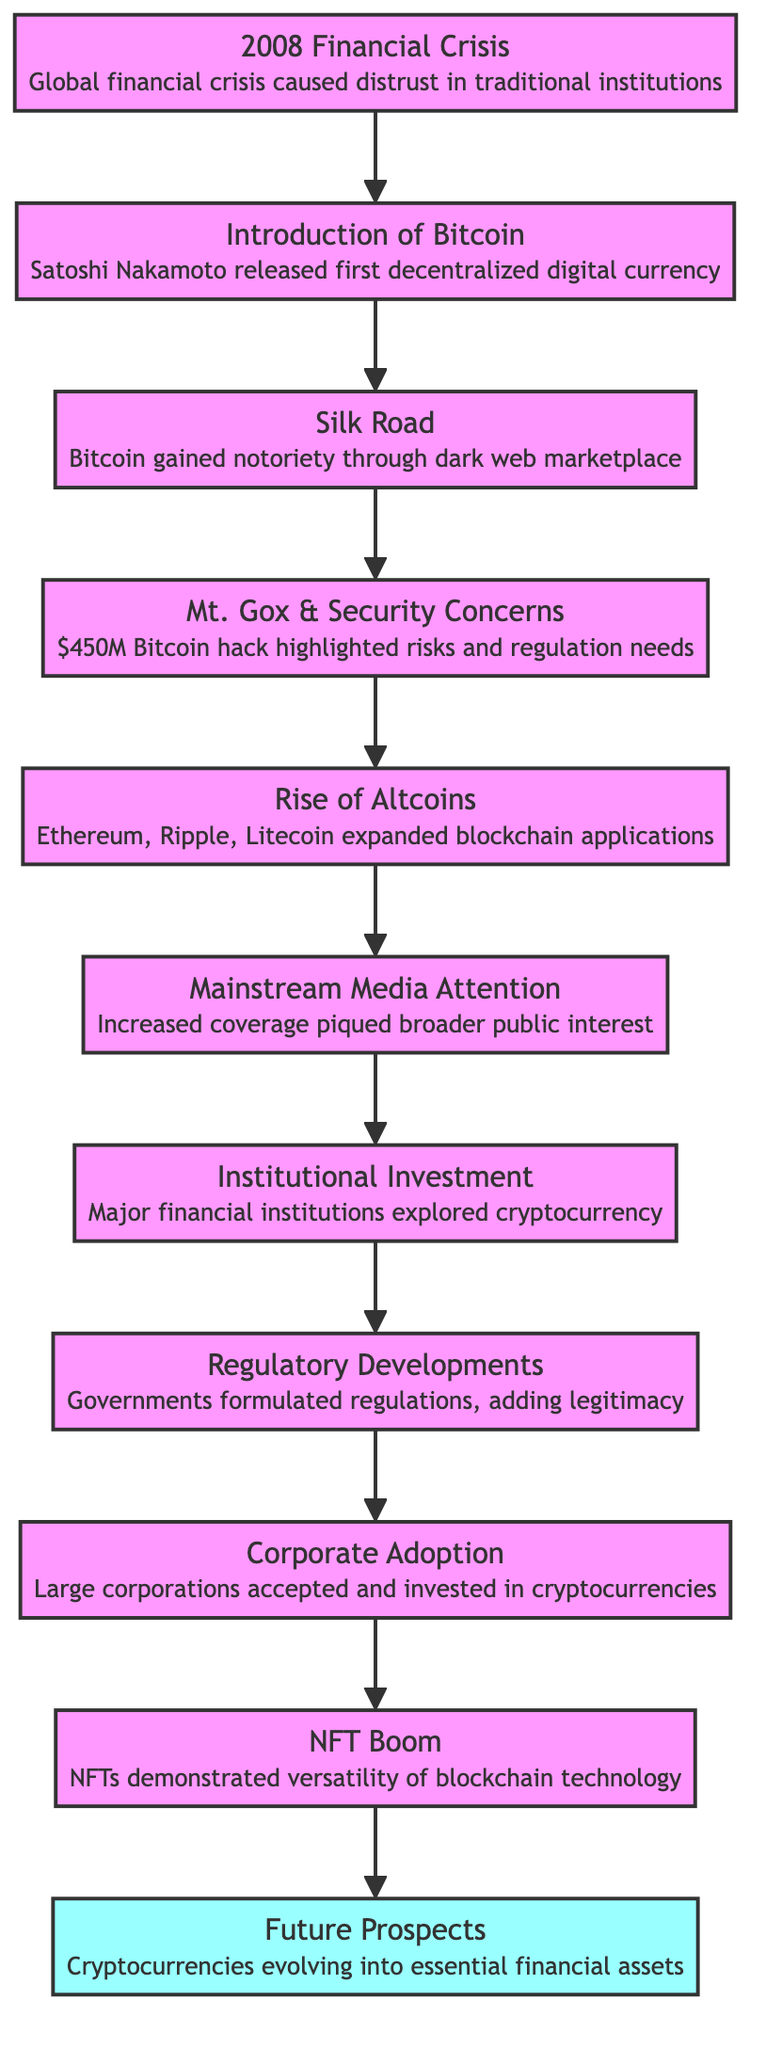What was the first cryptocurrency introduced? The diagram indicates that the first cryptocurrency introduced was Bitcoin in 2009, following the 2008 financial crisis.
Answer: Bitcoin What stage follows the Silk Road in the flow? According to the diagram, the node that follows Silk Road is Mt. Gox & Security Concerns.
Answer: Mt. Gox & Security Concerns How many major nodes are there in the flowchart before corporate adoption? Counting the distinct nodes in the flow that lead to corporate adoption, there are a total of 8 nodes before that stage, from the 2008 Financial Crisis to Mainstream Media Attention.
Answer: 8 What issue did the Mt. Gox incident highlight? The incident involving Mt. Gox highlighted security concerns related to cryptocurrency, as evidenced by the stolen funds and the subsequent discussion on regulation.
Answer: Security concerns Which stage indicates the transition of cryptocurrencies from niche to mainstream? The stage that signifies this transition is Corporate Adoption, where large companies began to integrate cryptocurrencies into their operations, showing mainstream acceptance.
Answer: Corporate Adoption What was the impact of the NFT boom on public attention? The NFT boom demonstrated the versatility of blockchain technology and significantly drew public attention towards various applications of cryptocurrencies, which is shown in the flowchart leading to the Future Prospects.
Answer: Draw public attention In which stage did major financial institutions start exploring cryptocurrencies? The chart specifies that major financial institutions began exploring cryptocurrencies during the Institutional Investment stage, marked as stage 7 in the flow.
Answer: Institutional Investment What regulatory action followed the rise of cryptocurrencies? Following the rise of cryptocurrencies, the chart indicates that Regulatory Developments began as governments formulated regulations to legitimize the markets.
Answer: Regulatory Developments What is the last stage in the flowchart? The last stage in the flow, as depicted in the diagram, is Future Prospects, which anticipates the evolution of cryptocurrencies as key financial assets.
Answer: Future Prospects 